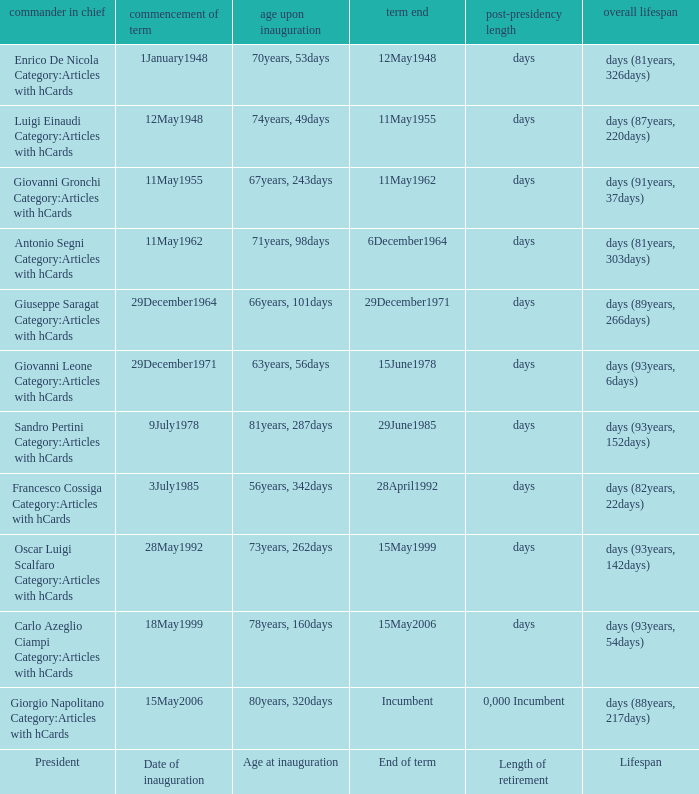What is the Length of retirement of the President with an Age at inauguration of 70years, 53days? Days. 